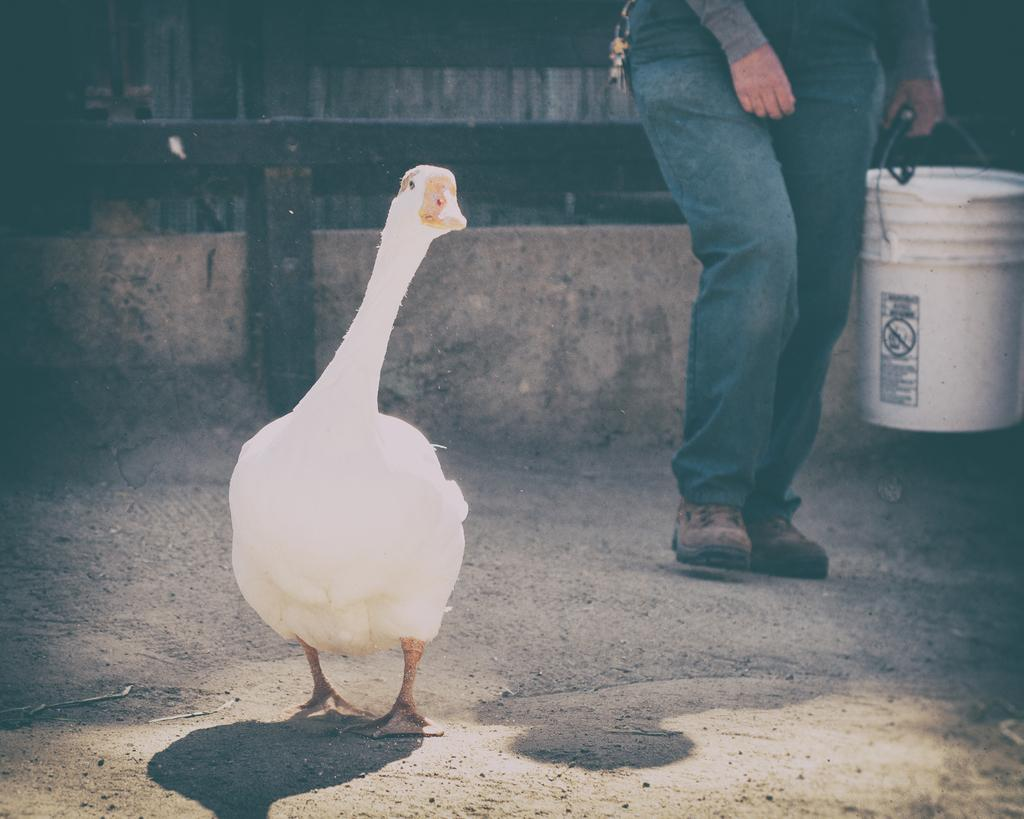What animal can be seen on the ground in the image? There is a bird on the ground in the image. What is the person holding in the image? The person is holding a bucket in the image. What structures can be seen in the background of the image? There is a wall and a fence in the background of the image. Can you tell me how many mice are playing in the band on the scale in the image? There are no mice, band, or scale present in the image. 